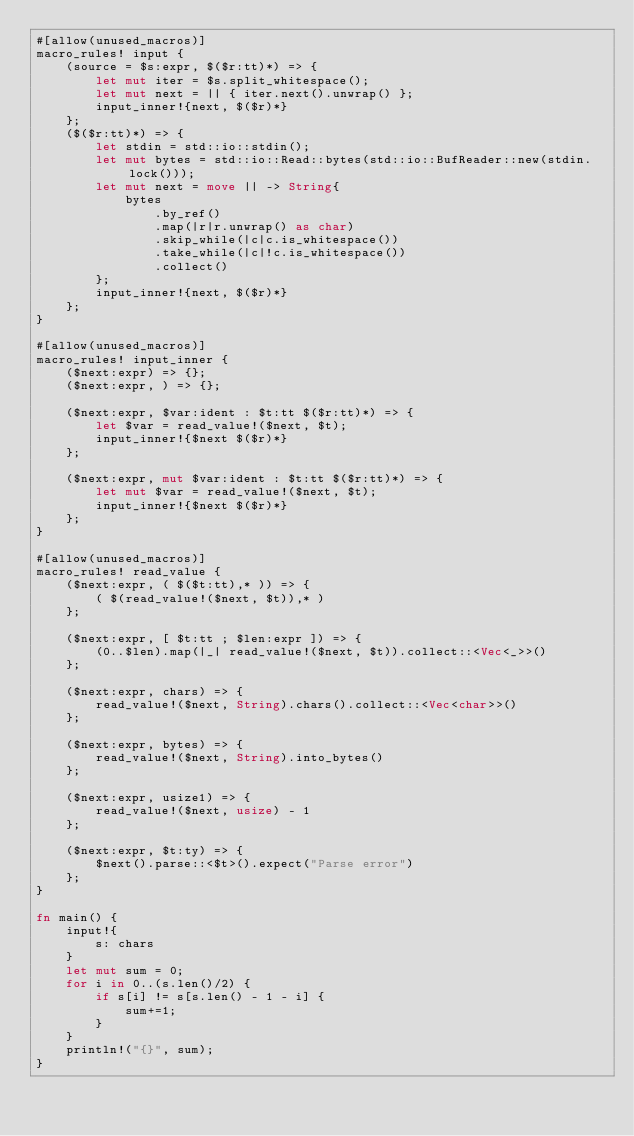Convert code to text. <code><loc_0><loc_0><loc_500><loc_500><_Rust_>#[allow(unused_macros)]
macro_rules! input {
    (source = $s:expr, $($r:tt)*) => {
        let mut iter = $s.split_whitespace();
        let mut next = || { iter.next().unwrap() };
        input_inner!{next, $($r)*}
    };
    ($($r:tt)*) => {
        let stdin = std::io::stdin();
        let mut bytes = std::io::Read::bytes(std::io::BufReader::new(stdin.lock()));
        let mut next = move || -> String{
            bytes
                .by_ref()
                .map(|r|r.unwrap() as char)
                .skip_while(|c|c.is_whitespace())
                .take_while(|c|!c.is_whitespace())
                .collect()
        };
        input_inner!{next, $($r)*}
    };
}

#[allow(unused_macros)]
macro_rules! input_inner {
    ($next:expr) => {};
    ($next:expr, ) => {};

    ($next:expr, $var:ident : $t:tt $($r:tt)*) => {
        let $var = read_value!($next, $t);
        input_inner!{$next $($r)*}
    };

    ($next:expr, mut $var:ident : $t:tt $($r:tt)*) => {
        let mut $var = read_value!($next, $t);
        input_inner!{$next $($r)*}
    };
}

#[allow(unused_macros)]
macro_rules! read_value {
    ($next:expr, ( $($t:tt),* )) => {
        ( $(read_value!($next, $t)),* )
    };

    ($next:expr, [ $t:tt ; $len:expr ]) => {
        (0..$len).map(|_| read_value!($next, $t)).collect::<Vec<_>>()
    };

    ($next:expr, chars) => {
        read_value!($next, String).chars().collect::<Vec<char>>()
    };

    ($next:expr, bytes) => {
        read_value!($next, String).into_bytes()
    };

    ($next:expr, usize1) => {
        read_value!($next, usize) - 1
    };

    ($next:expr, $t:ty) => {
        $next().parse::<$t>().expect("Parse error")
    };
}

fn main() {
    input!{
        s: chars
    }
    let mut sum = 0;
    for i in 0..(s.len()/2) {
        if s[i] != s[s.len() - 1 - i] {
            sum+=1;
        }
    }
    println!("{}", sum);
}</code> 